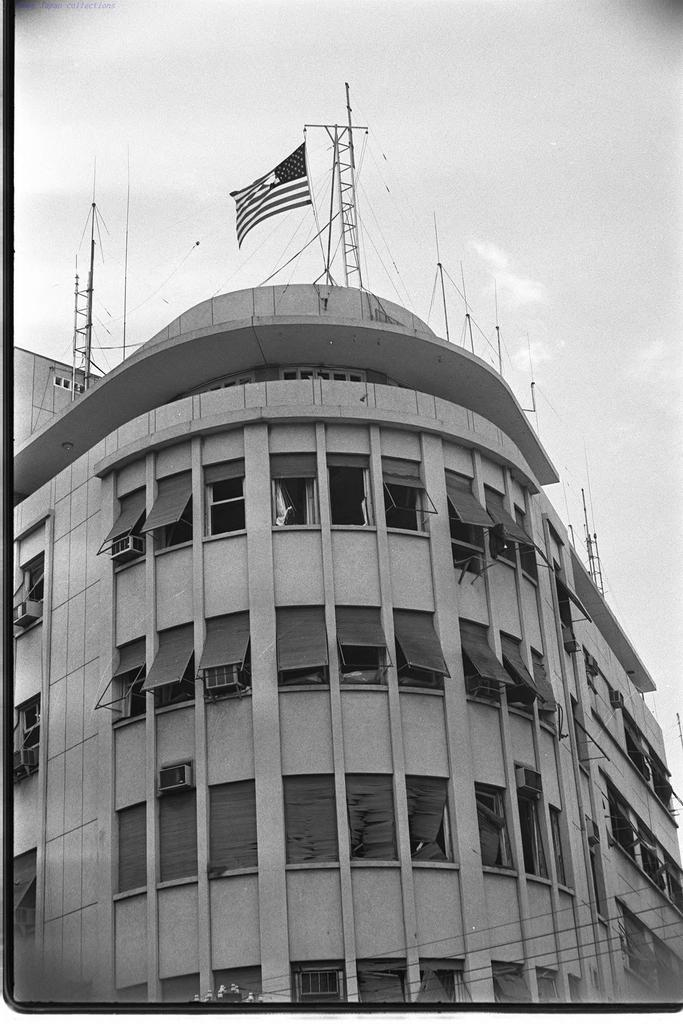What is the color scheme of the image? The image is black and white. What is the main structure in the image? There is a building in the image. What feature can be seen on the building? The building has windows. What are the vertical structures in the image? There are poles in the image. What type of objects can be seen in the image? There are objects in the image. Where is the flagpole located in the image? The flagpole is on the building. What is visible in the sky in the background? There are clouds in the sky in the background. What type of muscle is being flexed by the person in the image? There is no person present in the image, so it is not possible to determine if any muscles are being flexed. 